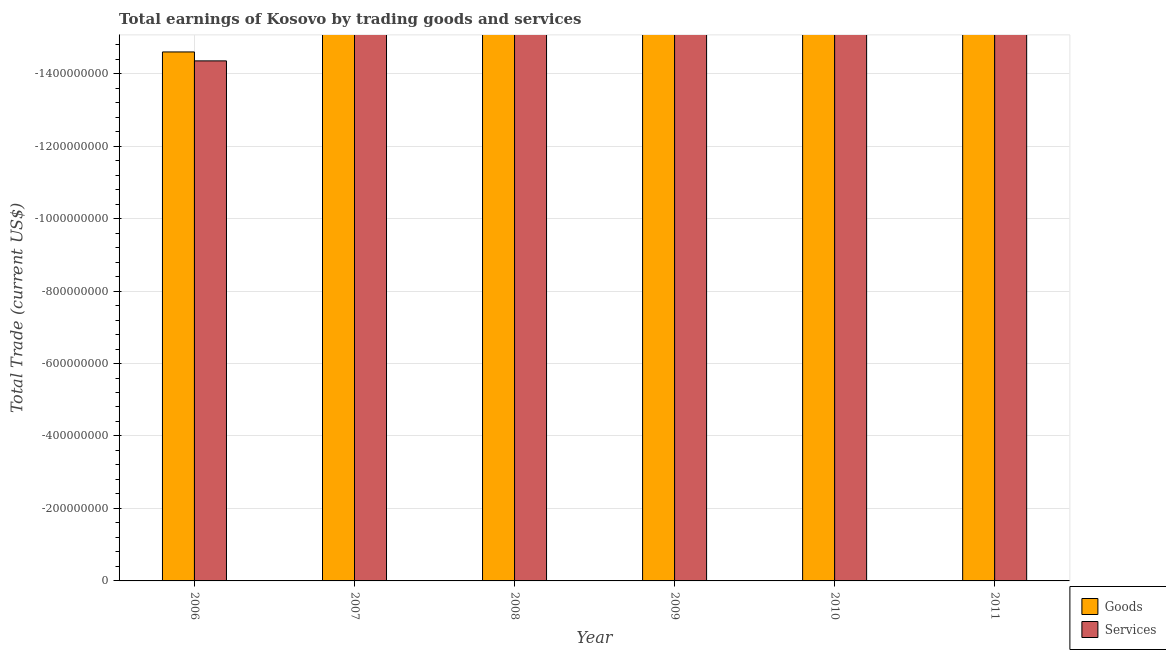How many different coloured bars are there?
Provide a succinct answer. 0. Are the number of bars on each tick of the X-axis equal?
Offer a terse response. Yes. How many bars are there on the 3rd tick from the left?
Ensure brevity in your answer.  0. What is the amount earned by trading services in 2011?
Your response must be concise. 0. Across all years, what is the minimum amount earned by trading services?
Offer a very short reply. 0. What is the difference between the amount earned by trading services in 2011 and the amount earned by trading goods in 2006?
Keep it short and to the point. 0. What is the average amount earned by trading services per year?
Your response must be concise. 0. How many bars are there?
Provide a succinct answer. 0. What is the difference between two consecutive major ticks on the Y-axis?
Keep it short and to the point. 2.00e+08. Are the values on the major ticks of Y-axis written in scientific E-notation?
Ensure brevity in your answer.  No. Does the graph contain grids?
Make the answer very short. Yes. How are the legend labels stacked?
Your answer should be compact. Vertical. What is the title of the graph?
Your response must be concise. Total earnings of Kosovo by trading goods and services. What is the label or title of the X-axis?
Ensure brevity in your answer.  Year. What is the label or title of the Y-axis?
Offer a very short reply. Total Trade (current US$). What is the Total Trade (current US$) in Goods in 2007?
Give a very brief answer. 0. What is the Total Trade (current US$) of Services in 2007?
Make the answer very short. 0. What is the Total Trade (current US$) of Goods in 2008?
Make the answer very short. 0. What is the Total Trade (current US$) in Services in 2008?
Provide a short and direct response. 0. What is the Total Trade (current US$) of Goods in 2009?
Keep it short and to the point. 0. What is the Total Trade (current US$) of Services in 2009?
Make the answer very short. 0. What is the Total Trade (current US$) of Services in 2010?
Provide a short and direct response. 0. What is the total Total Trade (current US$) in Services in the graph?
Give a very brief answer. 0. What is the average Total Trade (current US$) of Goods per year?
Make the answer very short. 0. 